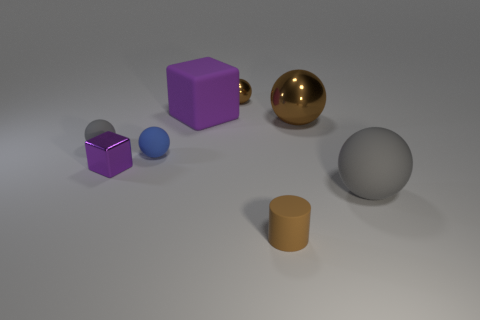Is there a brown metallic ball that is on the right side of the small brown thing left of the brown rubber cylinder?
Your response must be concise. Yes. Does the tiny cube that is behind the large gray thing have the same color as the big object that is on the left side of the small brown matte thing?
Your answer should be compact. Yes. What is the color of the small cylinder?
Provide a short and direct response. Brown. Are there any other things that have the same color as the shiny block?
Provide a succinct answer. Yes. There is a object that is right of the big purple matte cube and behind the large brown sphere; what color is it?
Make the answer very short. Brown. Is the size of the cube in front of the blue matte thing the same as the tiny gray ball?
Offer a terse response. Yes. Are there more gray objects behind the blue ball than big blue shiny blocks?
Your response must be concise. Yes. Is the big purple thing the same shape as the tiny brown shiny object?
Your response must be concise. No. The blue sphere has what size?
Your response must be concise. Small. Is the number of small brown matte cylinders behind the big cube greater than the number of purple things on the left side of the purple shiny thing?
Give a very brief answer. No. 